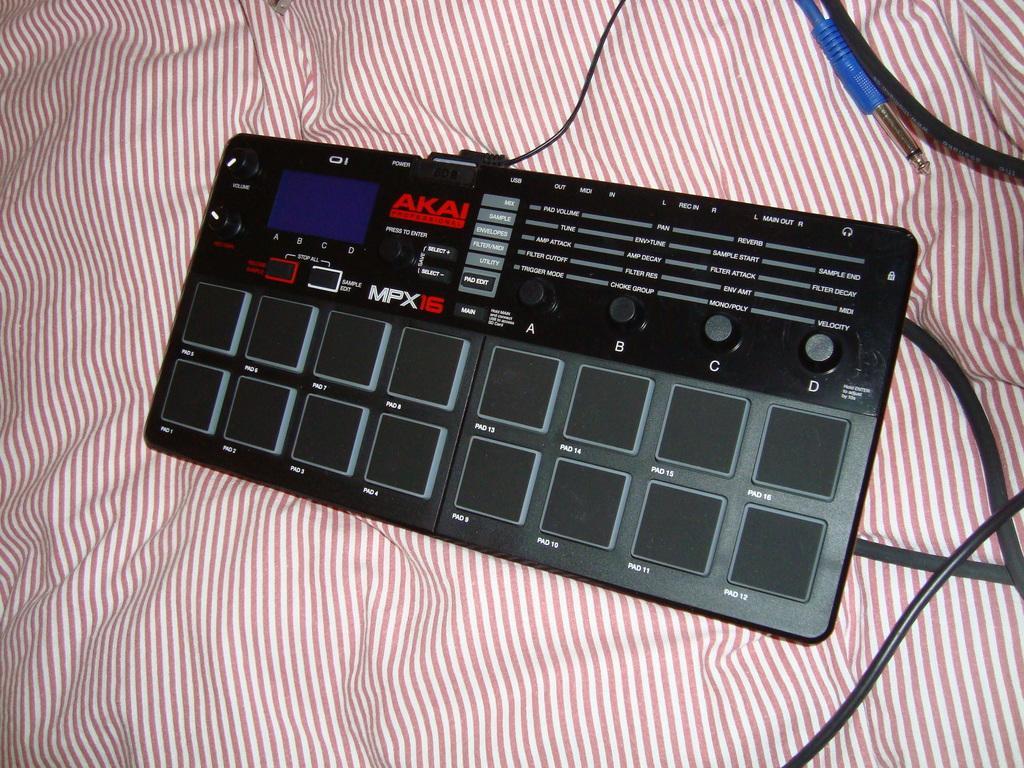Describe this image in one or two sentences. In this image we can see a device with some cables placed on the cloth surface. 